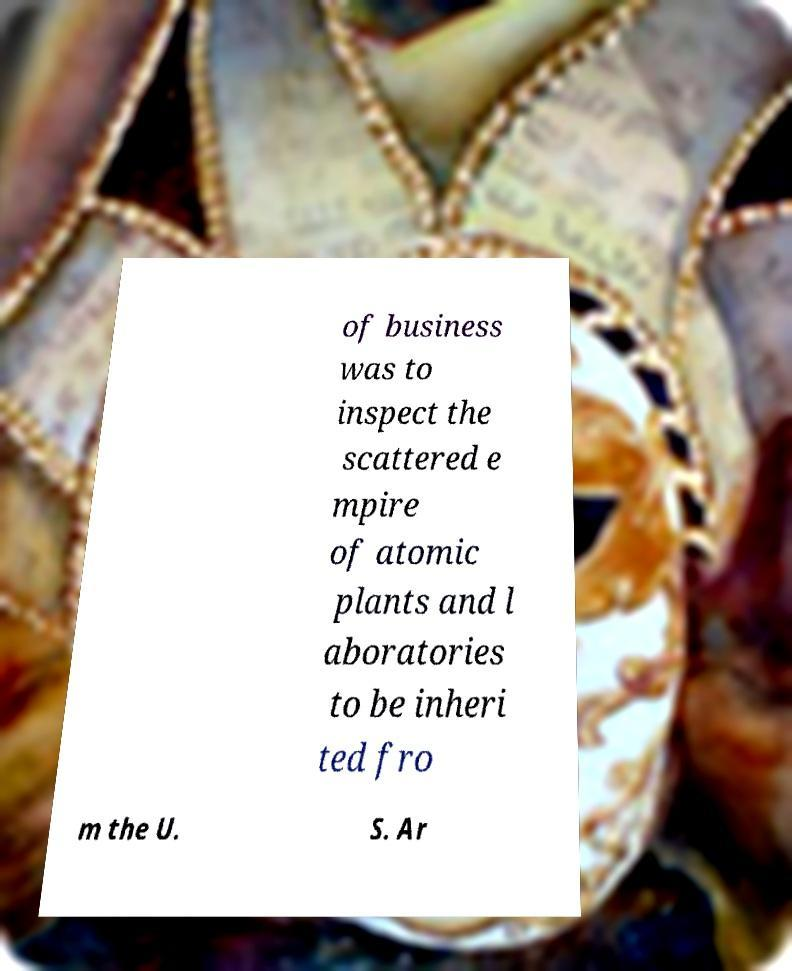I need the written content from this picture converted into text. Can you do that? of business was to inspect the scattered e mpire of atomic plants and l aboratories to be inheri ted fro m the U. S. Ar 